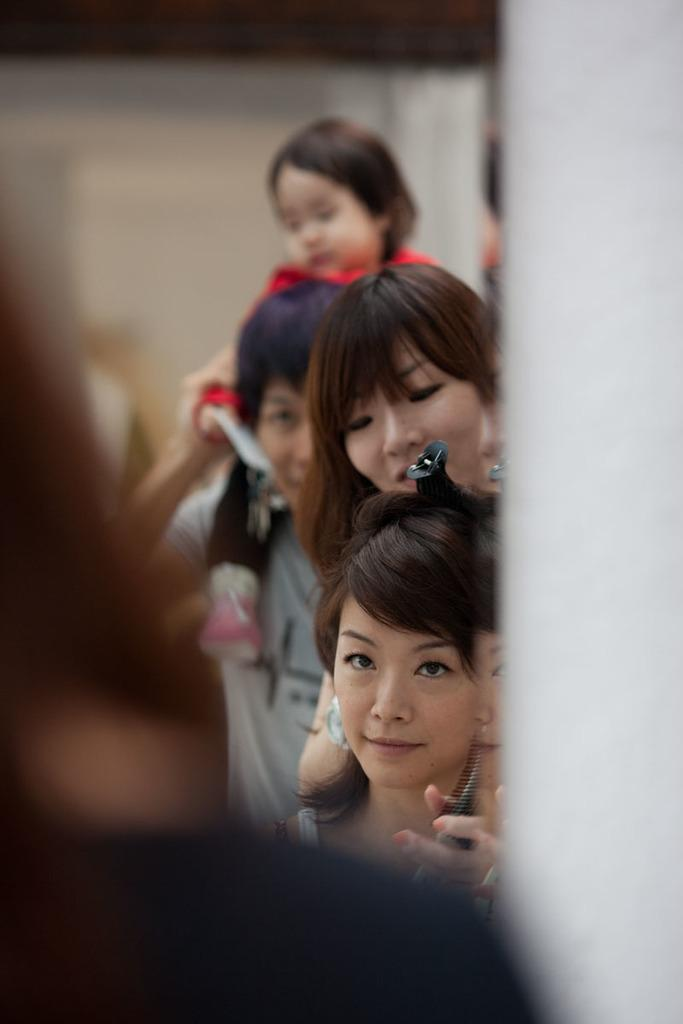What material is visible in the image? There is glass visible in the image. Can you describe the people in the image? There are people in the image, but their specific actions or characteristics are not mentioned in the provided facts. What color is the background of the image? The background of the image is white. How many flowers can be seen growing in the glass in the image? There are no flowers visible in the image; it features glass and people with a white background. What type of pollution is visible in the image? There is no reference to pollution in the image, as it only features glass, people, and a white background. 